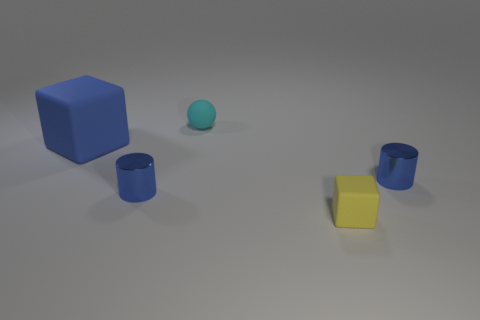Add 4 blue cubes. How many objects exist? 9 Subtract all blocks. How many objects are left? 3 Subtract all brown matte cubes. Subtract all large cubes. How many objects are left? 4 Add 5 yellow rubber cubes. How many yellow rubber cubes are left? 6 Add 4 tiny yellow things. How many tiny yellow things exist? 5 Subtract 0 yellow cylinders. How many objects are left? 5 